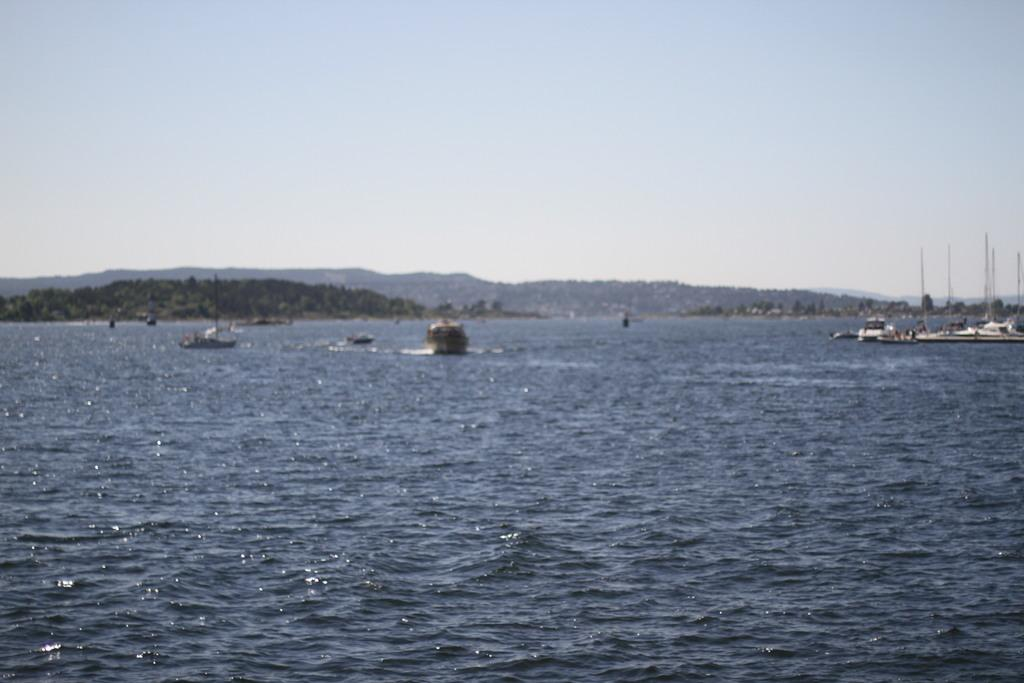What is on the water in the image? There are boats on the water in the image. What type of vegetation can be seen in the image? There are trees visible in the image. What geographical features are present in the image? There are hills in the image. What is visible in the background of the image? The sky is visible in the background of the image. What type of brass instrument is being played by the spiders on the skate in the image? There are no spiders, brass instruments, spiders, or skates present in the image. 